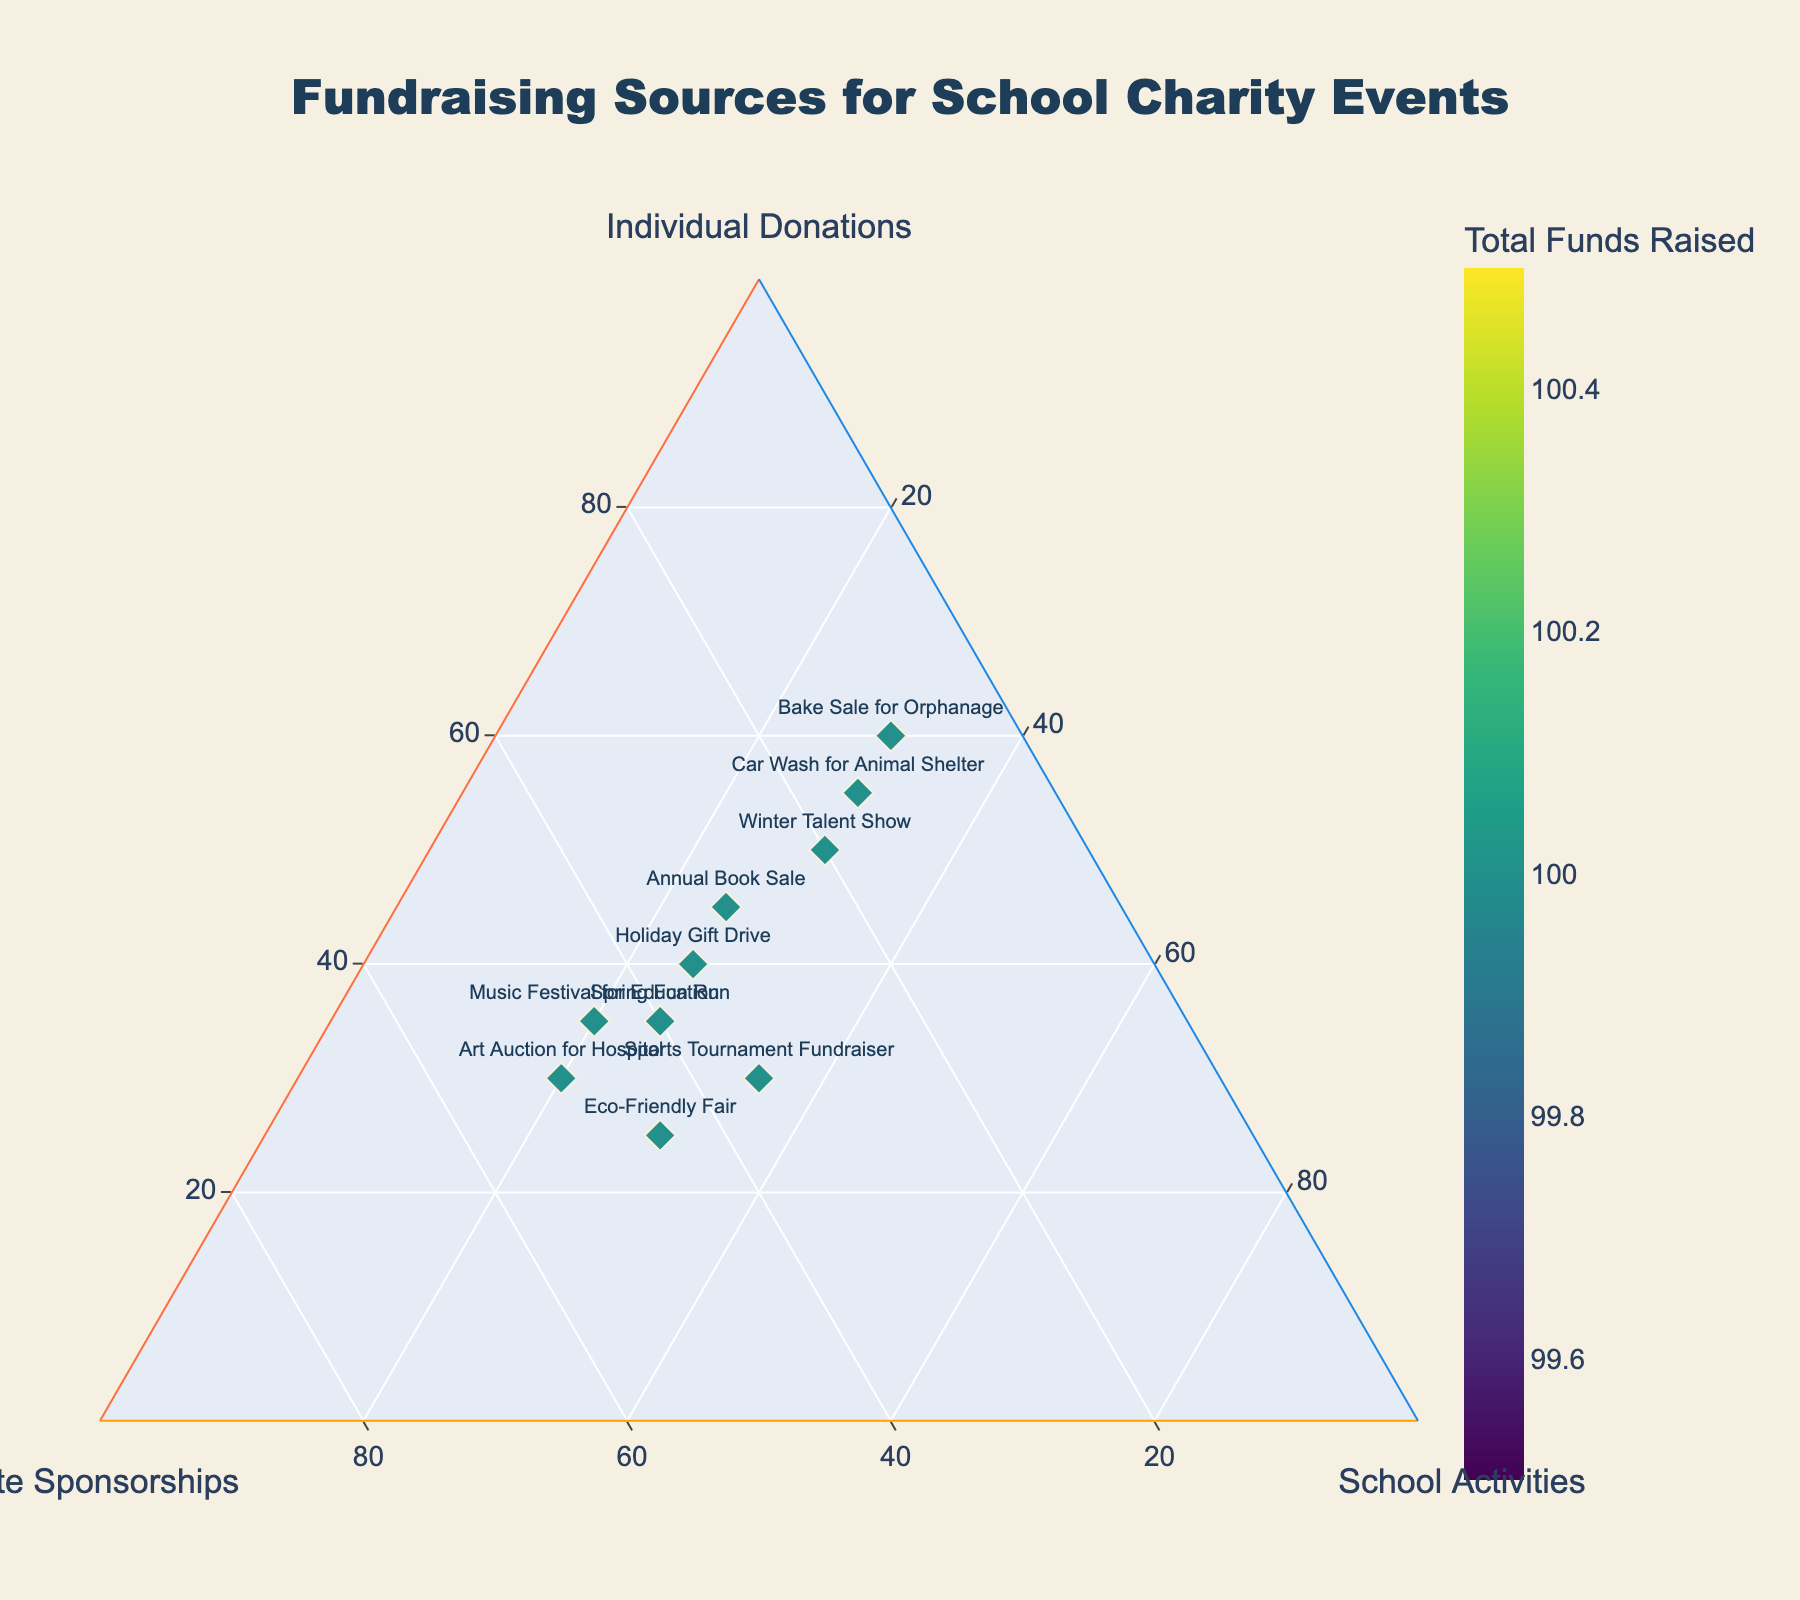What is the title of the figure? The title of the figure is displayed prominently at the top. It describes the type of data visualized, giving context to the fundraising events and their sources.
Answer: Fundraising Sources for School Charity Events How many events are represented in the figure? The figure has markers, each representing a fundraising event. Count the number of markers or the number of labels.
Answer: 10 Which event has the highest percentage of individual donations? The event with the highest percentage of individual donations would have the marker closest to the 'Individual Donations' axis.
Answer: Bake Sale for Orphanage Which event has an equal percentage for individual donations, corporate sponsorships, and school activities? An event with an equal distribution would be near the center of the ternary plot.
Answer: Sports Tournament Fundraiser Which event raised the most total funds? The color scale in the plot represents total funds raised. The event with the darkest color marker indicates the highest total funds raised.
Answer: Music Festival for Education What's the percentage breakdown of fundraising sources for the Art Auction for Hospital? Locate the Art Auction for Hospital marker and read off the percentage values from the respective axes or the text labels.
Answer: 30% Individual Donations, 50% Corporate Sponsorships, 20% School Activities Compare the total funds raised by the Spring Fun Run and Eco-Friendly Fair. Which one raised more? Check the color of the markers for Spring Fun Run and Eco-Friendly Fair. The one with the darker shade raised more funds.
Answer: Spring Fun Run Identify the data points where Corporate Sponsorships exceed 40% of total funds raised. Find markers closest to the 'Corporate Sponsorships' axis and check if they exceed the 40% line.
Answer: Spring Fun Run, Eco-Friendly Fair, Music Festival for Education Which events have an equal contribution from school activities and individual donations? Find markers equidistant from the 'School Activities' and 'Individual Donations' axes, indicating similar percentages.
Answer: Winter Talent Show and Car Wash for Animal Shelter What is the average percentage of school activities across all events? Sum up the percentage of school activities for all events and divide by the number of events.
Answer: (25 + 25 + 30 + 30 + 20 + 30 + 25 + 30 + 20 + 35) / 10 = 27% 